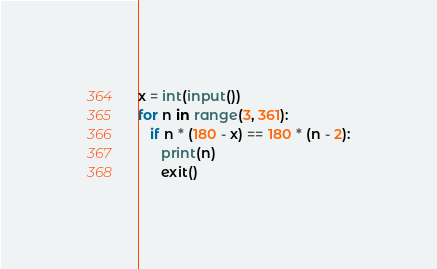Convert code to text. <code><loc_0><loc_0><loc_500><loc_500><_Python_>x = int(input())
for n in range(3, 361):
   if n * (180 - x) == 180 * (n - 2):
      print(n)
      exit()</code> 